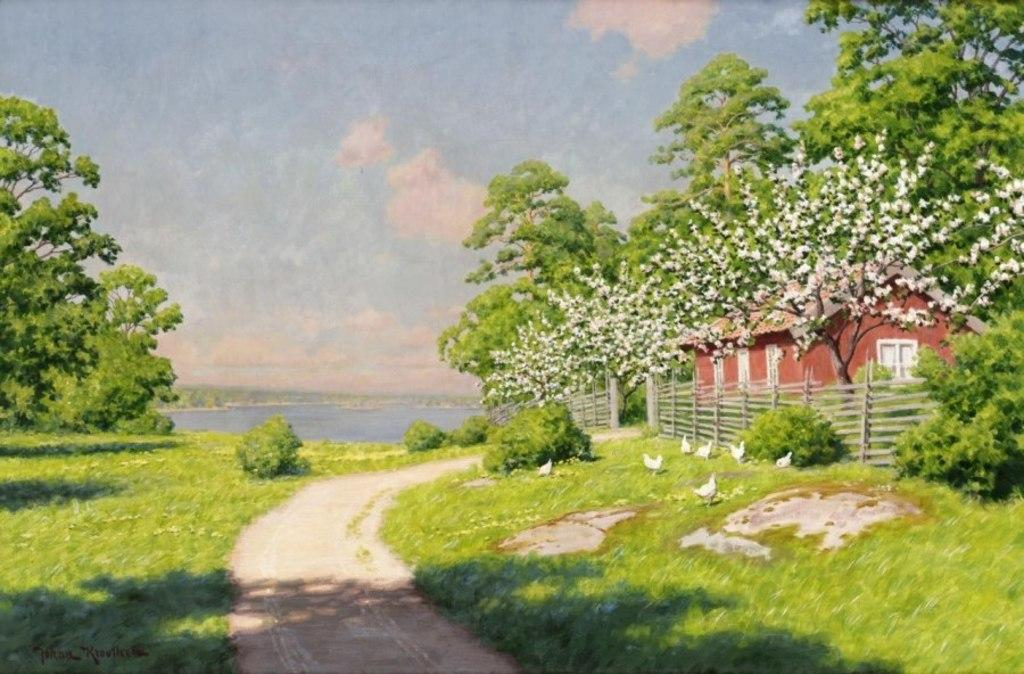What is the main feature of the image? There is a path in the image. What can be found on the other side of the path? On the other side of the path, there is grass, plants, and trees. Can you describe the house in the image? There is a house in the image. What safety feature is present in the image? A railing is present in the image. What is visible in the background of the image? Water and the sky are visible in the background of the image. What can be seen in the sky? Clouds are present in the sky. What type of animal is creating the path in the image? There is no animal creating the path in the image; it is a static feature. Are there any cacti visible in the image? There is no mention of cacti in the provided facts, so we cannot determine if they are present in the image. 